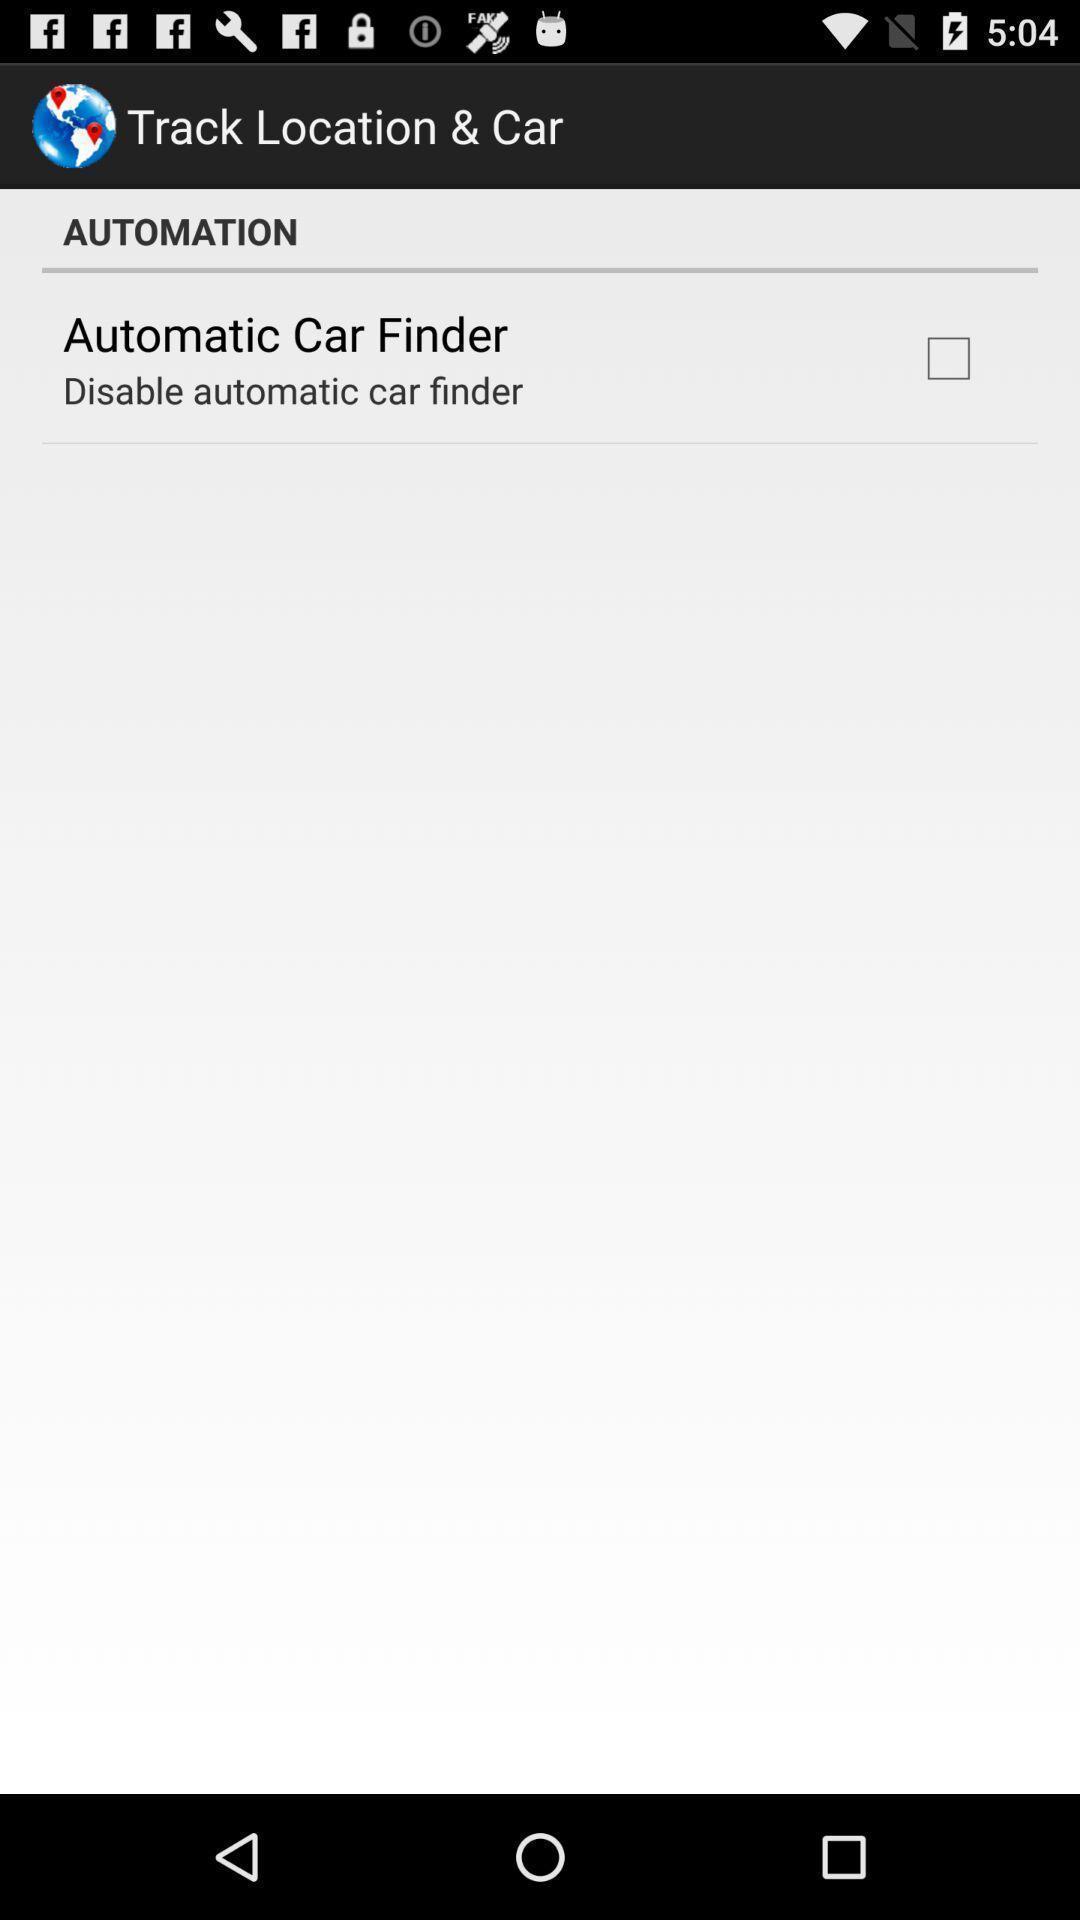Describe the visual elements of this screenshot. Screen showing automatic car finder option. 